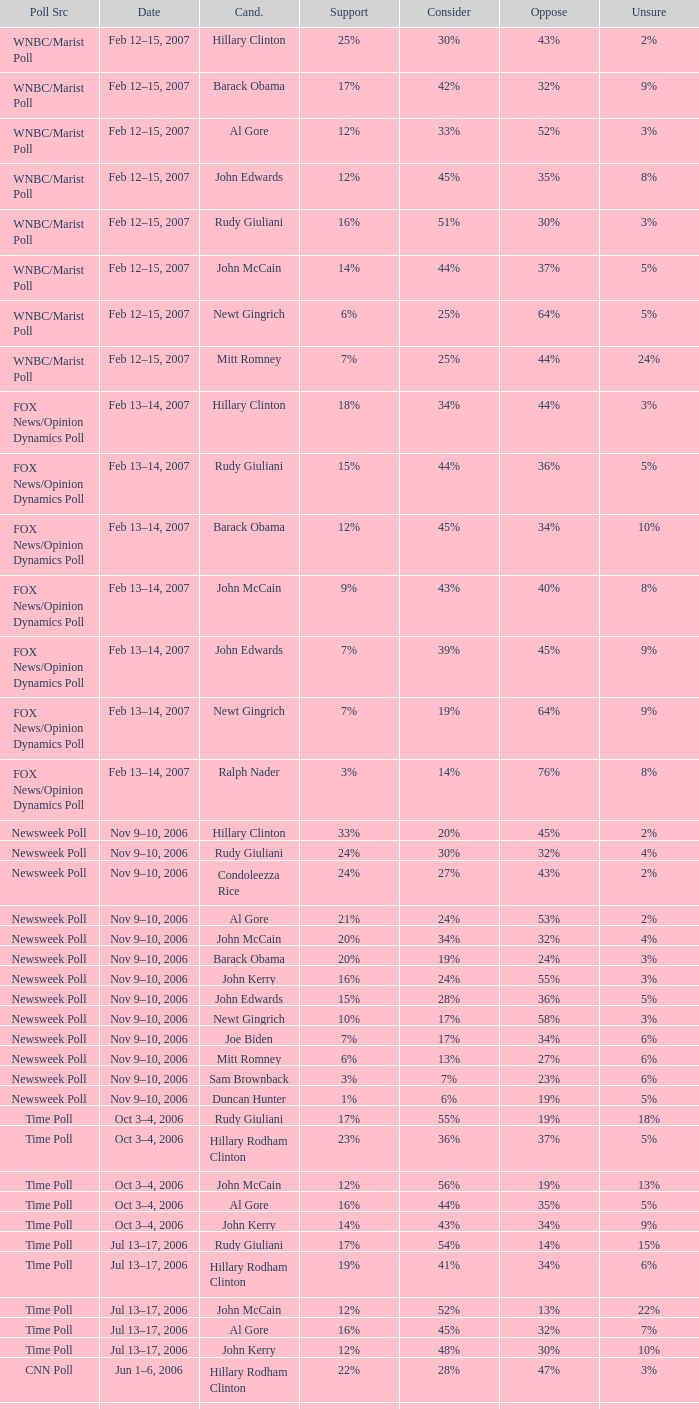What percentage of people were opposed to the candidate based on the Time Poll poll that showed 6% of people were unsure? 34%. 